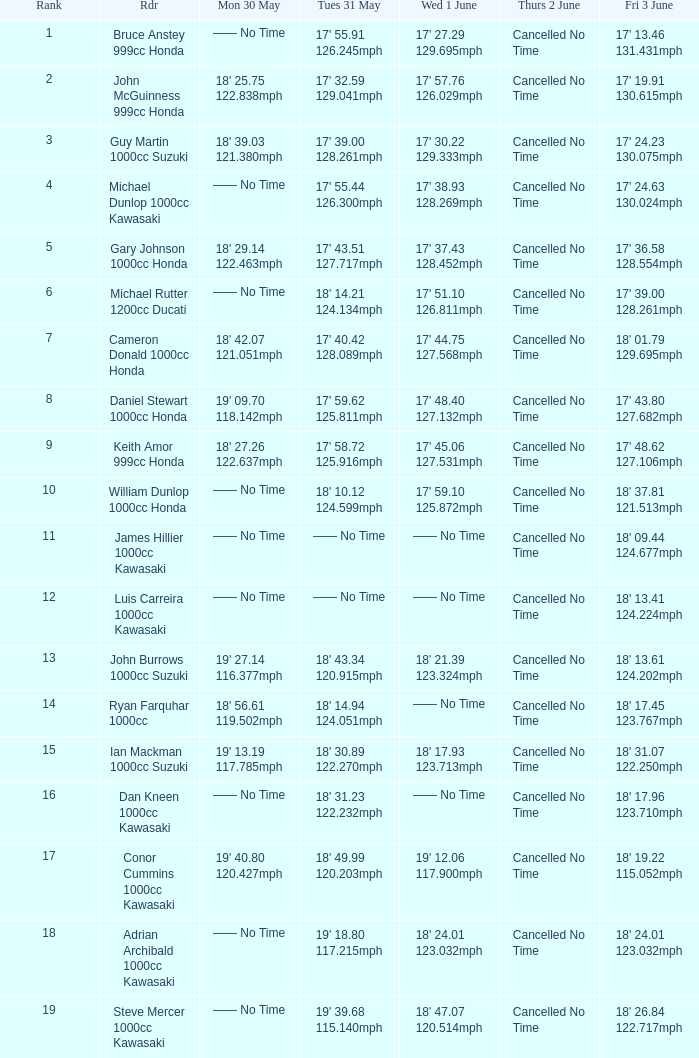What is the Mon 30 May time for the rider whose Fri 3 June time was 17' 13.46 131.431mph? —— No Time. 